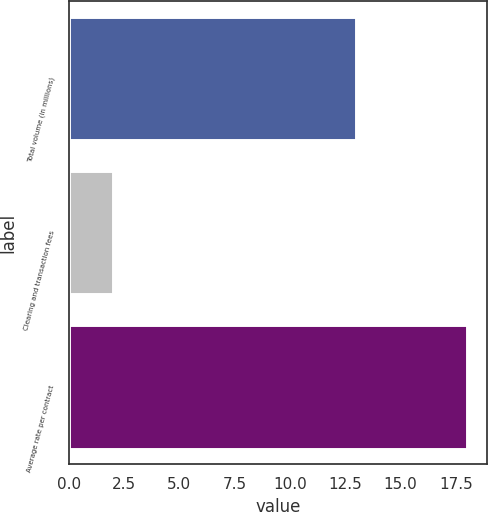<chart> <loc_0><loc_0><loc_500><loc_500><bar_chart><fcel>Total volume (in millions)<fcel>Clearing and transaction fees<fcel>Average rate per contract<nl><fcel>13<fcel>2<fcel>18<nl></chart> 